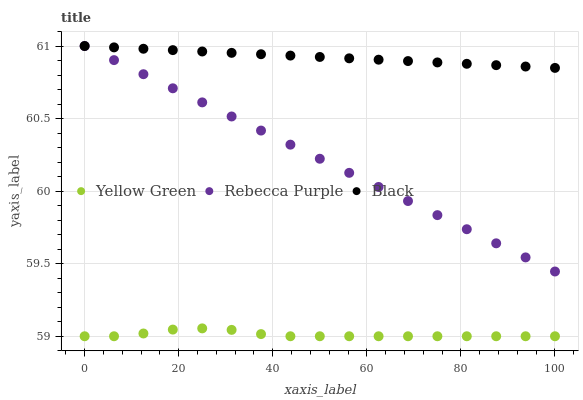Does Yellow Green have the minimum area under the curve?
Answer yes or no. Yes. Does Black have the maximum area under the curve?
Answer yes or no. Yes. Does Rebecca Purple have the minimum area under the curve?
Answer yes or no. No. Does Rebecca Purple have the maximum area under the curve?
Answer yes or no. No. Is Rebecca Purple the smoothest?
Answer yes or no. Yes. Is Yellow Green the roughest?
Answer yes or no. Yes. Is Yellow Green the smoothest?
Answer yes or no. No. Is Rebecca Purple the roughest?
Answer yes or no. No. Does Yellow Green have the lowest value?
Answer yes or no. Yes. Does Rebecca Purple have the lowest value?
Answer yes or no. No. Does Rebecca Purple have the highest value?
Answer yes or no. Yes. Does Yellow Green have the highest value?
Answer yes or no. No. Is Yellow Green less than Black?
Answer yes or no. Yes. Is Rebecca Purple greater than Yellow Green?
Answer yes or no. Yes. Does Black intersect Rebecca Purple?
Answer yes or no. Yes. Is Black less than Rebecca Purple?
Answer yes or no. No. Is Black greater than Rebecca Purple?
Answer yes or no. No. Does Yellow Green intersect Black?
Answer yes or no. No. 